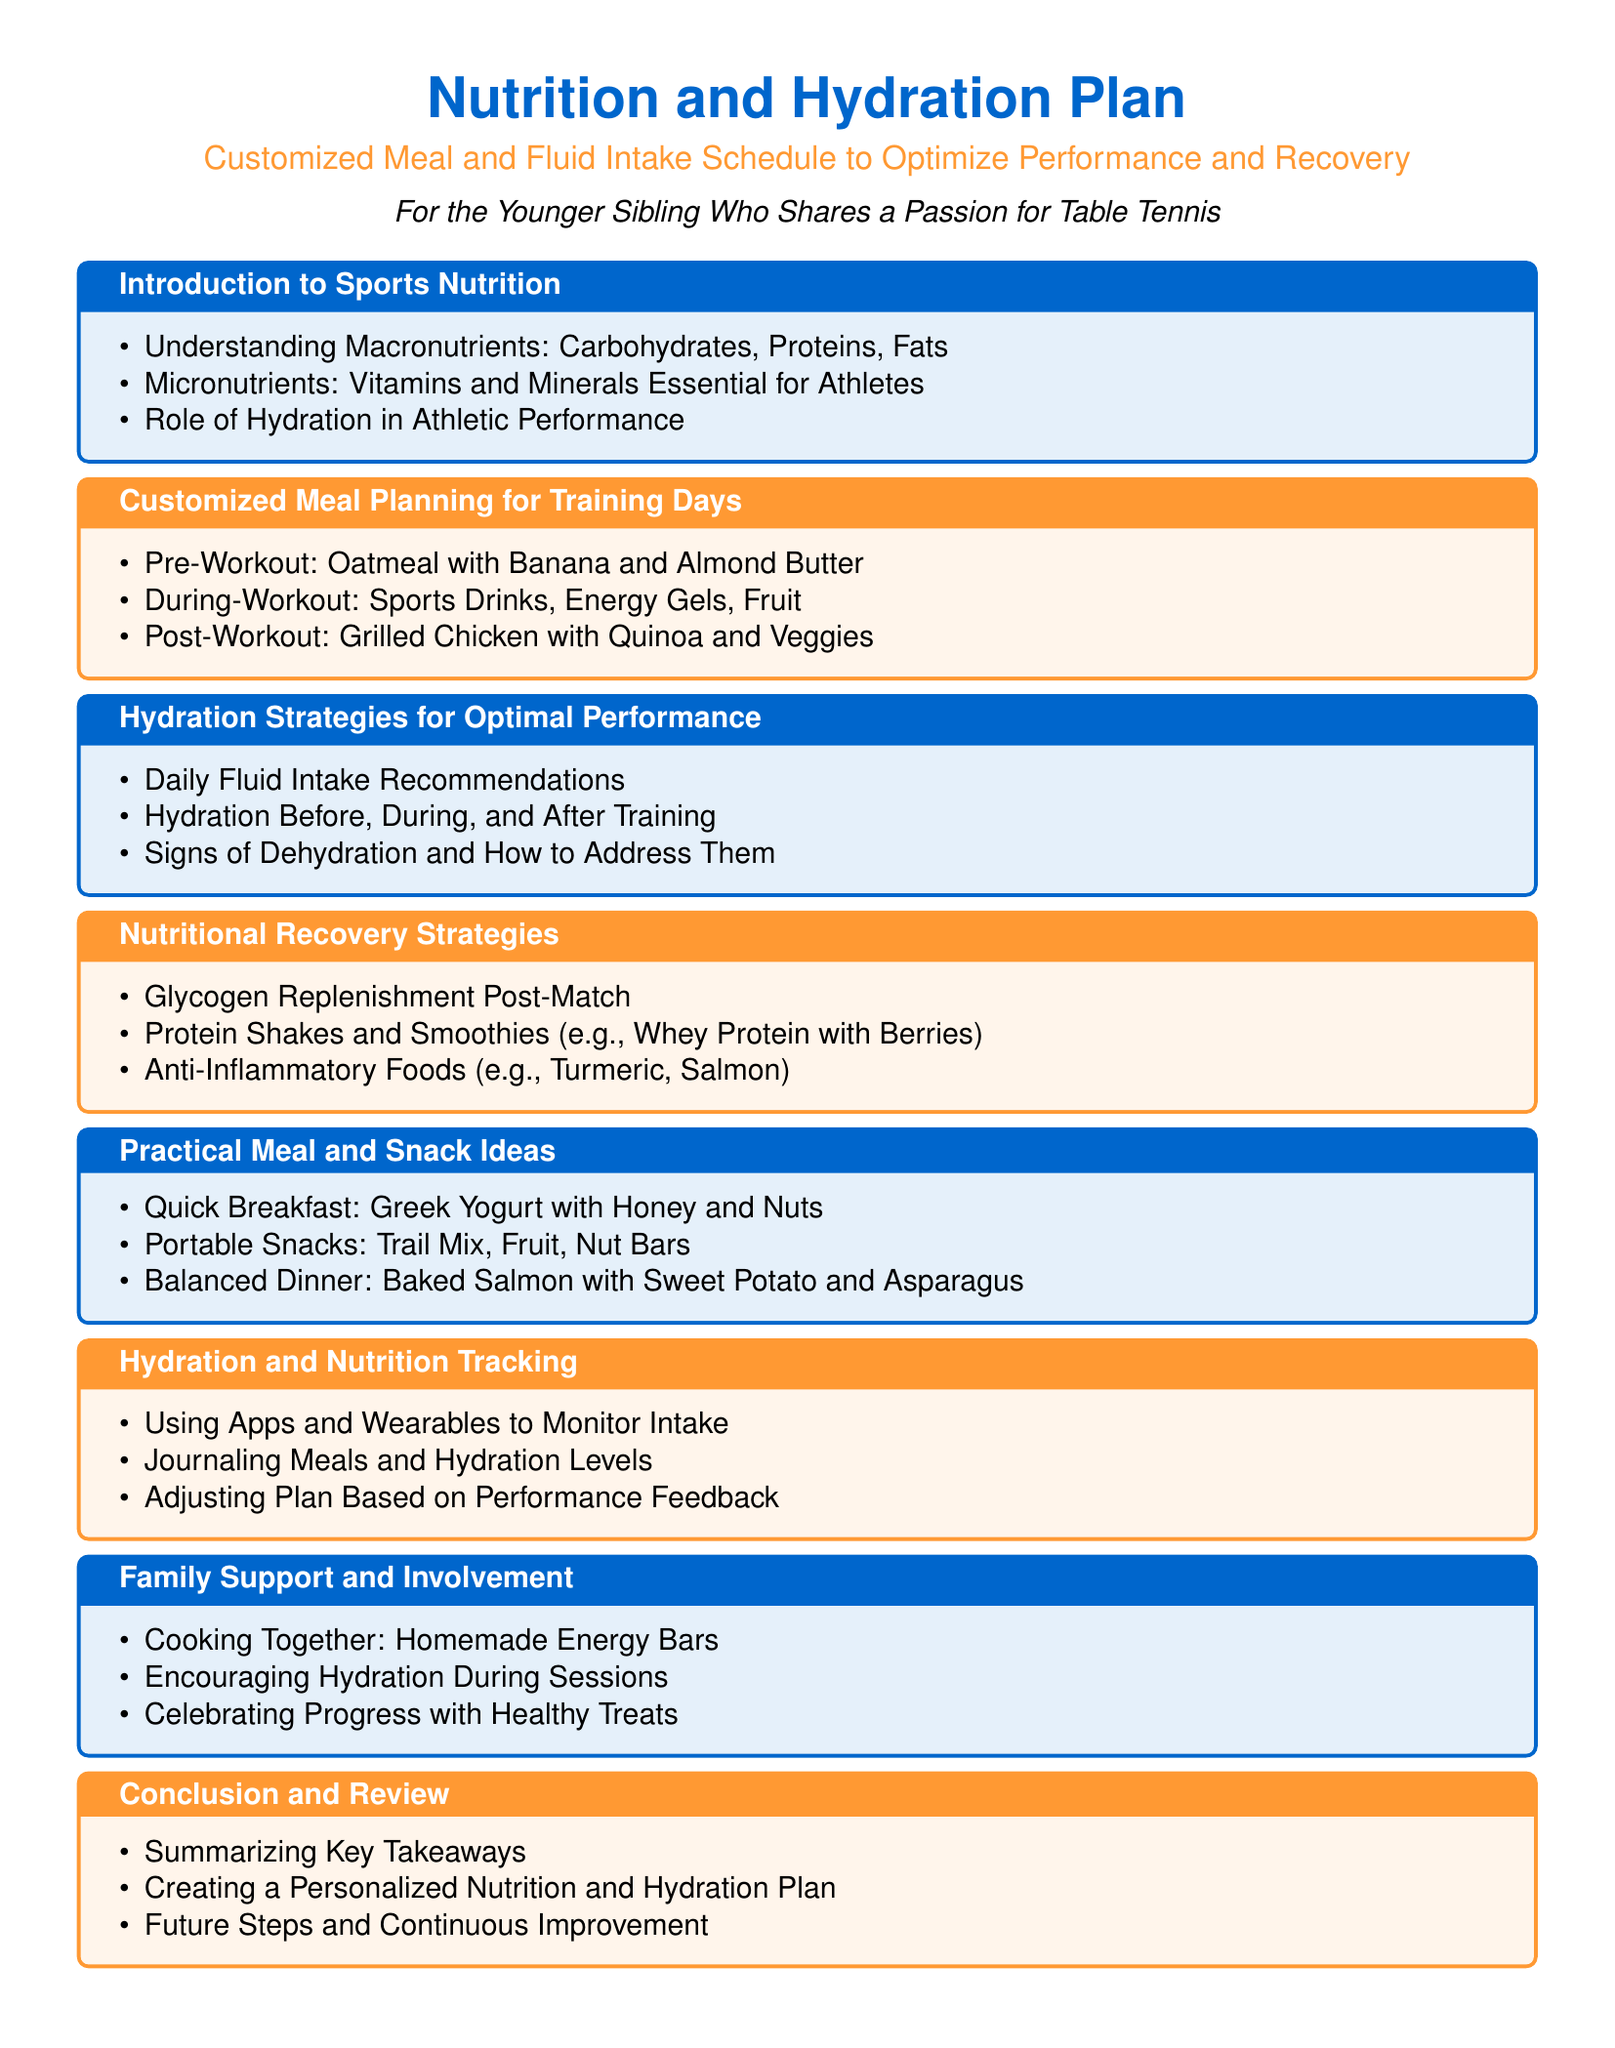what are the three macronutrients? The three macronutrients mentioned in the document are carbohydrates, proteins, and fats.
Answer: carbohydrates, proteins, fats what is one pre-workout meal suggested? The document suggests oatmeal with banana and almond butter as a pre-workout meal.
Answer: oatmeal with banana and almond butter during which part of the workout should sports drinks be consumed? Sports drinks should be consumed during the workout, as indicated in the document.
Answer: during-workout what is a recommended protein source for recovery? A recommended protein source for recovery mentioned is grilled chicken.
Answer: grilled chicken what type of foods are suggested for anti-inflammatory effects? The document suggests turmeric and salmon as anti-inflammatory foods.
Answer: turmeric, salmon how can hydration levels be tracked, according to the document? The document mentions using apps and wearables to monitor hydration levels.
Answer: apps and wearables what is one activity for family support mentioned in the document? The document states cooking together as a form of family support.
Answer: cooking together what is the focus of the conclusion section? The conclusion section focuses on summarizing key takeaways from the plan.
Answer: summarizing key takeaways 